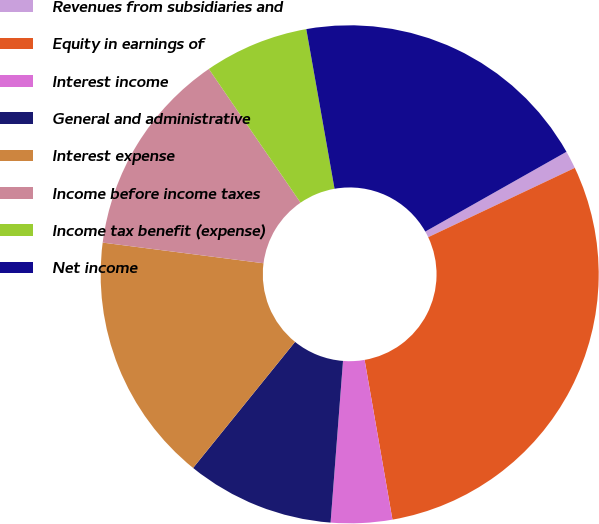Convert chart. <chart><loc_0><loc_0><loc_500><loc_500><pie_chart><fcel>Revenues from subsidiaries and<fcel>Equity in earnings of<fcel>Interest income<fcel>General and administrative<fcel>Interest expense<fcel>Income before income taxes<fcel>Income tax benefit (expense)<fcel>Net income<nl><fcel>1.16%<fcel>29.28%<fcel>3.97%<fcel>9.6%<fcel>16.21%<fcel>13.4%<fcel>6.78%<fcel>19.6%<nl></chart> 